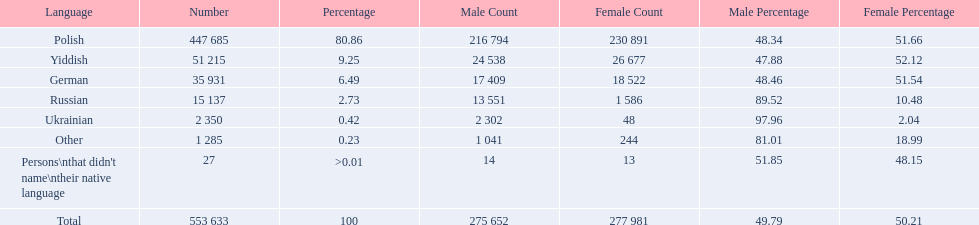Which language options are listed? Polish, Yiddish, German, Russian, Ukrainian, Other, Persons\nthat didn't name\ntheir native language. Of these, which did .42% of the people select? Ukrainian. 